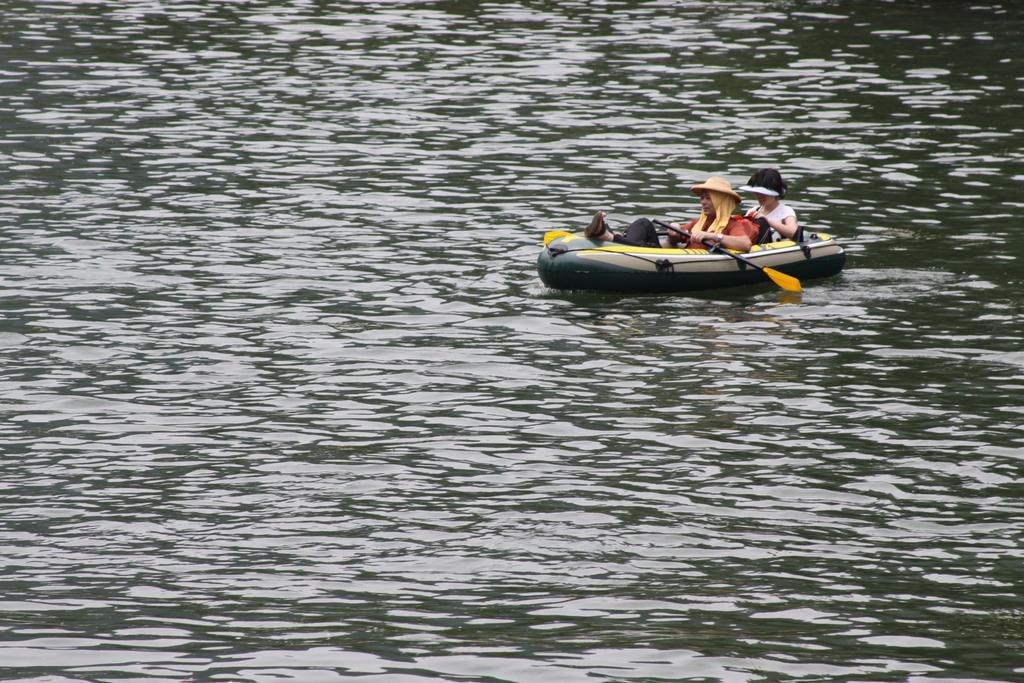How would you summarize this image in a sentence or two? In this image we can see two women holding paddles in their hands are sitting in an inflatable boat which is floating in the water. 